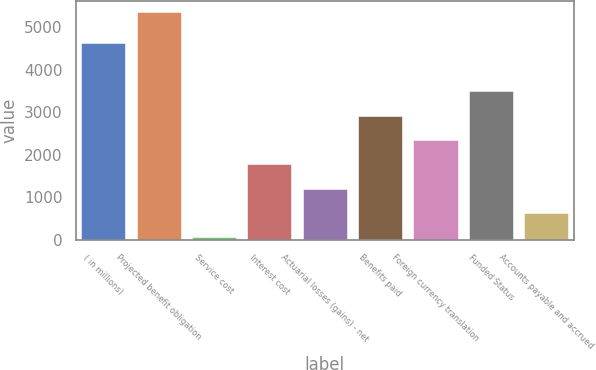Convert chart to OTSL. <chart><loc_0><loc_0><loc_500><loc_500><bar_chart><fcel>( in millions)<fcel>Projected benefit obligation<fcel>Service cost<fcel>Interest cost<fcel>Actuarial losses (gains) - net<fcel>Benefits paid<fcel>Foreign currency translation<fcel>Funded Status<fcel>Accounts payable and accrued<nl><fcel>4631.4<fcel>5349<fcel>57<fcel>1772.4<fcel>1200.6<fcel>2916<fcel>2344.2<fcel>3487.8<fcel>628.8<nl></chart> 